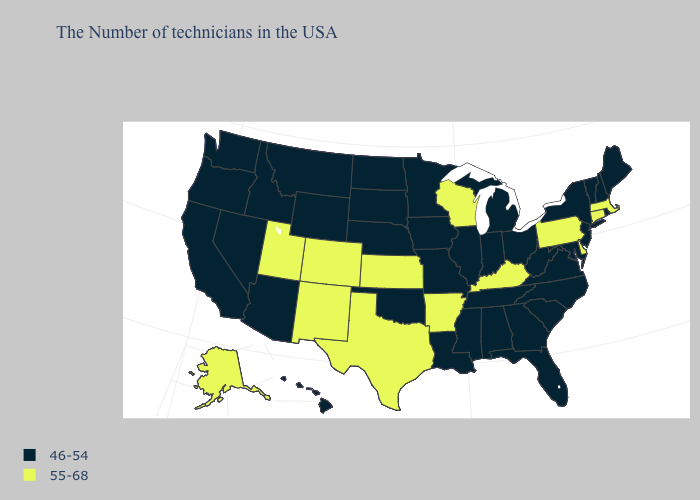What is the highest value in the USA?
Give a very brief answer. 55-68. Which states have the lowest value in the USA?
Be succinct. Maine, Rhode Island, New Hampshire, Vermont, New York, New Jersey, Maryland, Virginia, North Carolina, South Carolina, West Virginia, Ohio, Florida, Georgia, Michigan, Indiana, Alabama, Tennessee, Illinois, Mississippi, Louisiana, Missouri, Minnesota, Iowa, Nebraska, Oklahoma, South Dakota, North Dakota, Wyoming, Montana, Arizona, Idaho, Nevada, California, Washington, Oregon, Hawaii. What is the lowest value in the West?
Quick response, please. 46-54. Does Connecticut have the highest value in the Northeast?
Write a very short answer. Yes. What is the value of Texas?
Be succinct. 55-68. How many symbols are there in the legend?
Keep it brief. 2. Name the states that have a value in the range 46-54?
Keep it brief. Maine, Rhode Island, New Hampshire, Vermont, New York, New Jersey, Maryland, Virginia, North Carolina, South Carolina, West Virginia, Ohio, Florida, Georgia, Michigan, Indiana, Alabama, Tennessee, Illinois, Mississippi, Louisiana, Missouri, Minnesota, Iowa, Nebraska, Oklahoma, South Dakota, North Dakota, Wyoming, Montana, Arizona, Idaho, Nevada, California, Washington, Oregon, Hawaii. What is the highest value in states that border Maryland?
Be succinct. 55-68. Among the states that border Texas , does Arkansas have the lowest value?
Write a very short answer. No. Which states have the lowest value in the MidWest?
Concise answer only. Ohio, Michigan, Indiana, Illinois, Missouri, Minnesota, Iowa, Nebraska, South Dakota, North Dakota. What is the highest value in states that border New Mexico?
Be succinct. 55-68. Name the states that have a value in the range 55-68?
Quick response, please. Massachusetts, Connecticut, Delaware, Pennsylvania, Kentucky, Wisconsin, Arkansas, Kansas, Texas, Colorado, New Mexico, Utah, Alaska. Among the states that border Wyoming , does Nebraska have the lowest value?
Concise answer only. Yes. Name the states that have a value in the range 46-54?
Short answer required. Maine, Rhode Island, New Hampshire, Vermont, New York, New Jersey, Maryland, Virginia, North Carolina, South Carolina, West Virginia, Ohio, Florida, Georgia, Michigan, Indiana, Alabama, Tennessee, Illinois, Mississippi, Louisiana, Missouri, Minnesota, Iowa, Nebraska, Oklahoma, South Dakota, North Dakota, Wyoming, Montana, Arizona, Idaho, Nevada, California, Washington, Oregon, Hawaii. Which states have the lowest value in the USA?
Short answer required. Maine, Rhode Island, New Hampshire, Vermont, New York, New Jersey, Maryland, Virginia, North Carolina, South Carolina, West Virginia, Ohio, Florida, Georgia, Michigan, Indiana, Alabama, Tennessee, Illinois, Mississippi, Louisiana, Missouri, Minnesota, Iowa, Nebraska, Oklahoma, South Dakota, North Dakota, Wyoming, Montana, Arizona, Idaho, Nevada, California, Washington, Oregon, Hawaii. 